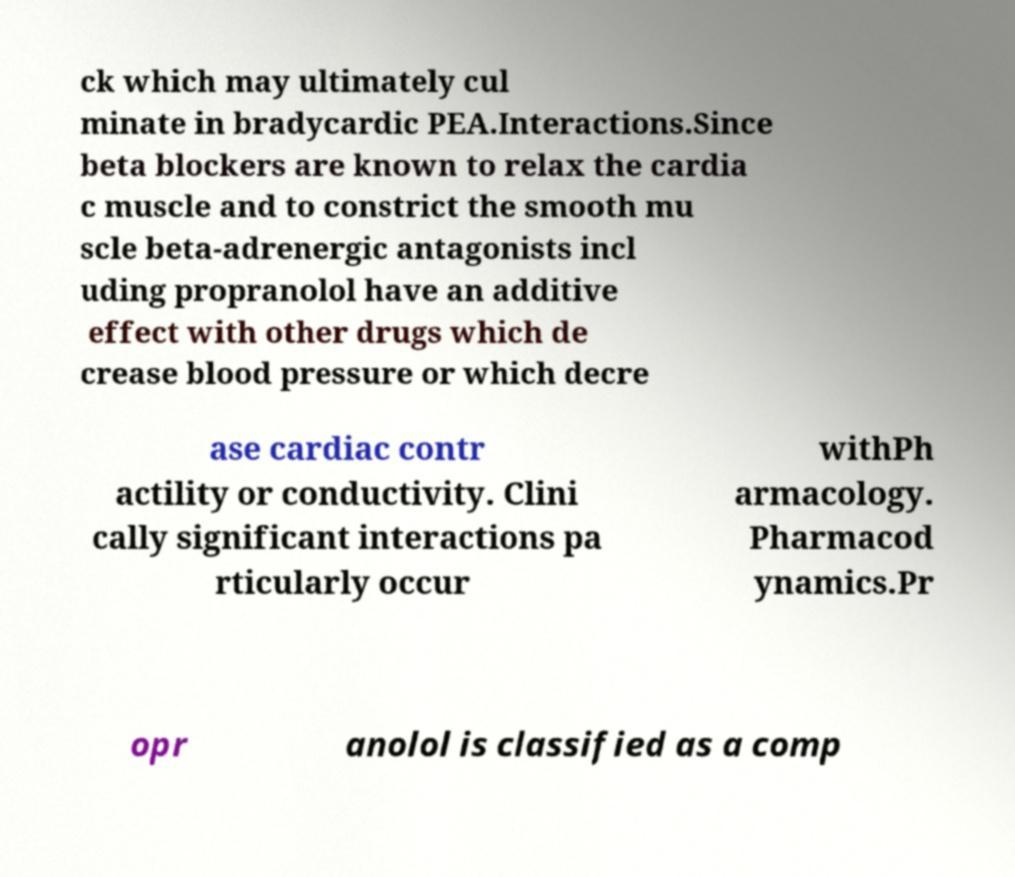There's text embedded in this image that I need extracted. Can you transcribe it verbatim? ck which may ultimately cul minate in bradycardic PEA.Interactions.Since beta blockers are known to relax the cardia c muscle and to constrict the smooth mu scle beta-adrenergic antagonists incl uding propranolol have an additive effect with other drugs which de crease blood pressure or which decre ase cardiac contr actility or conductivity. Clini cally significant interactions pa rticularly occur withPh armacology. Pharmacod ynamics.Pr opr anolol is classified as a comp 